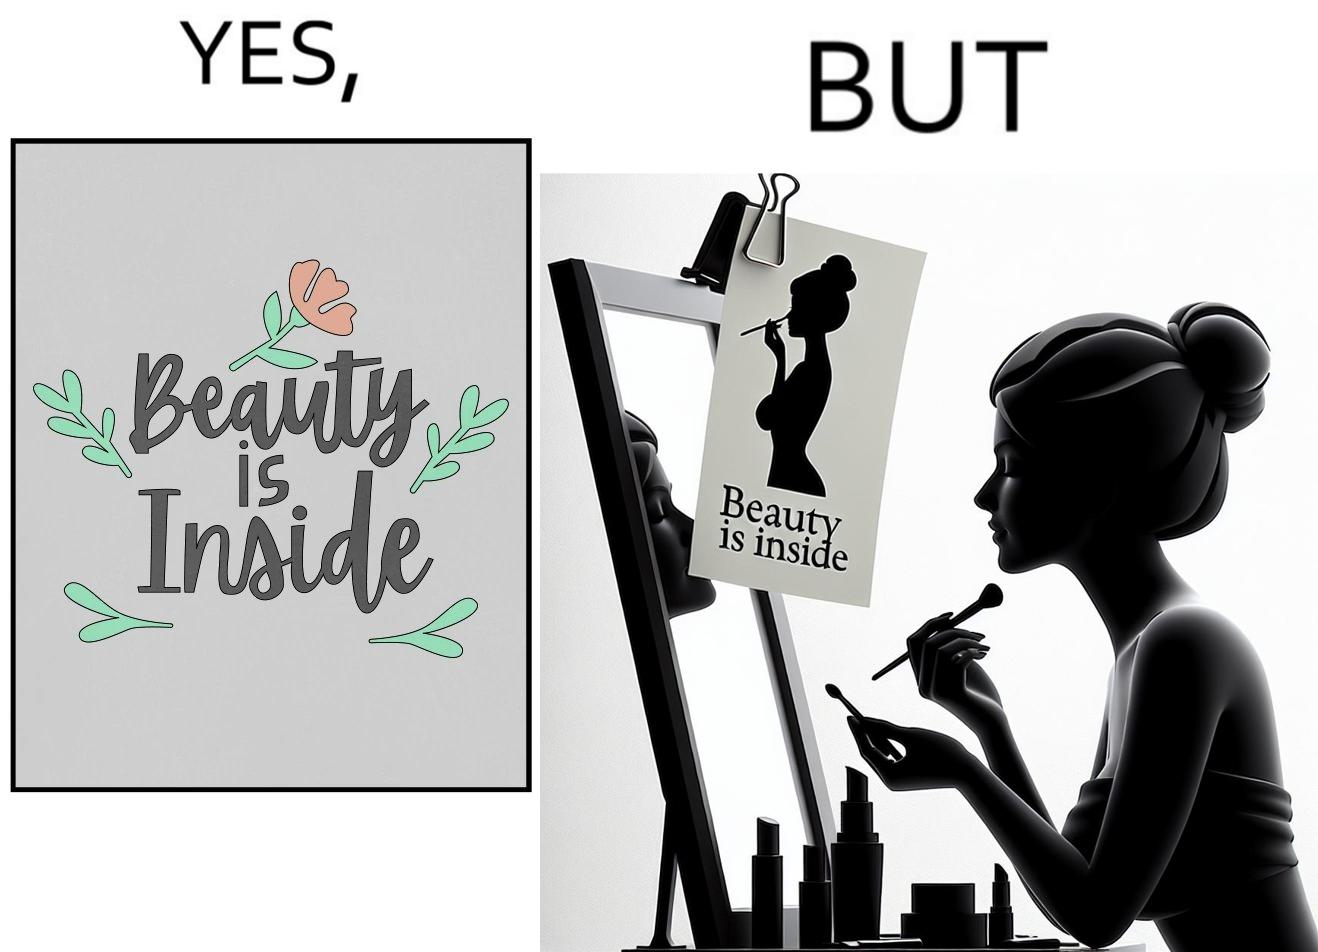Explain the humor or irony in this image. The image is satirical because while the text on the paper says that beauty lies inside, the woman ignores the note and continues to apply makeup to improve her outer beauty. 